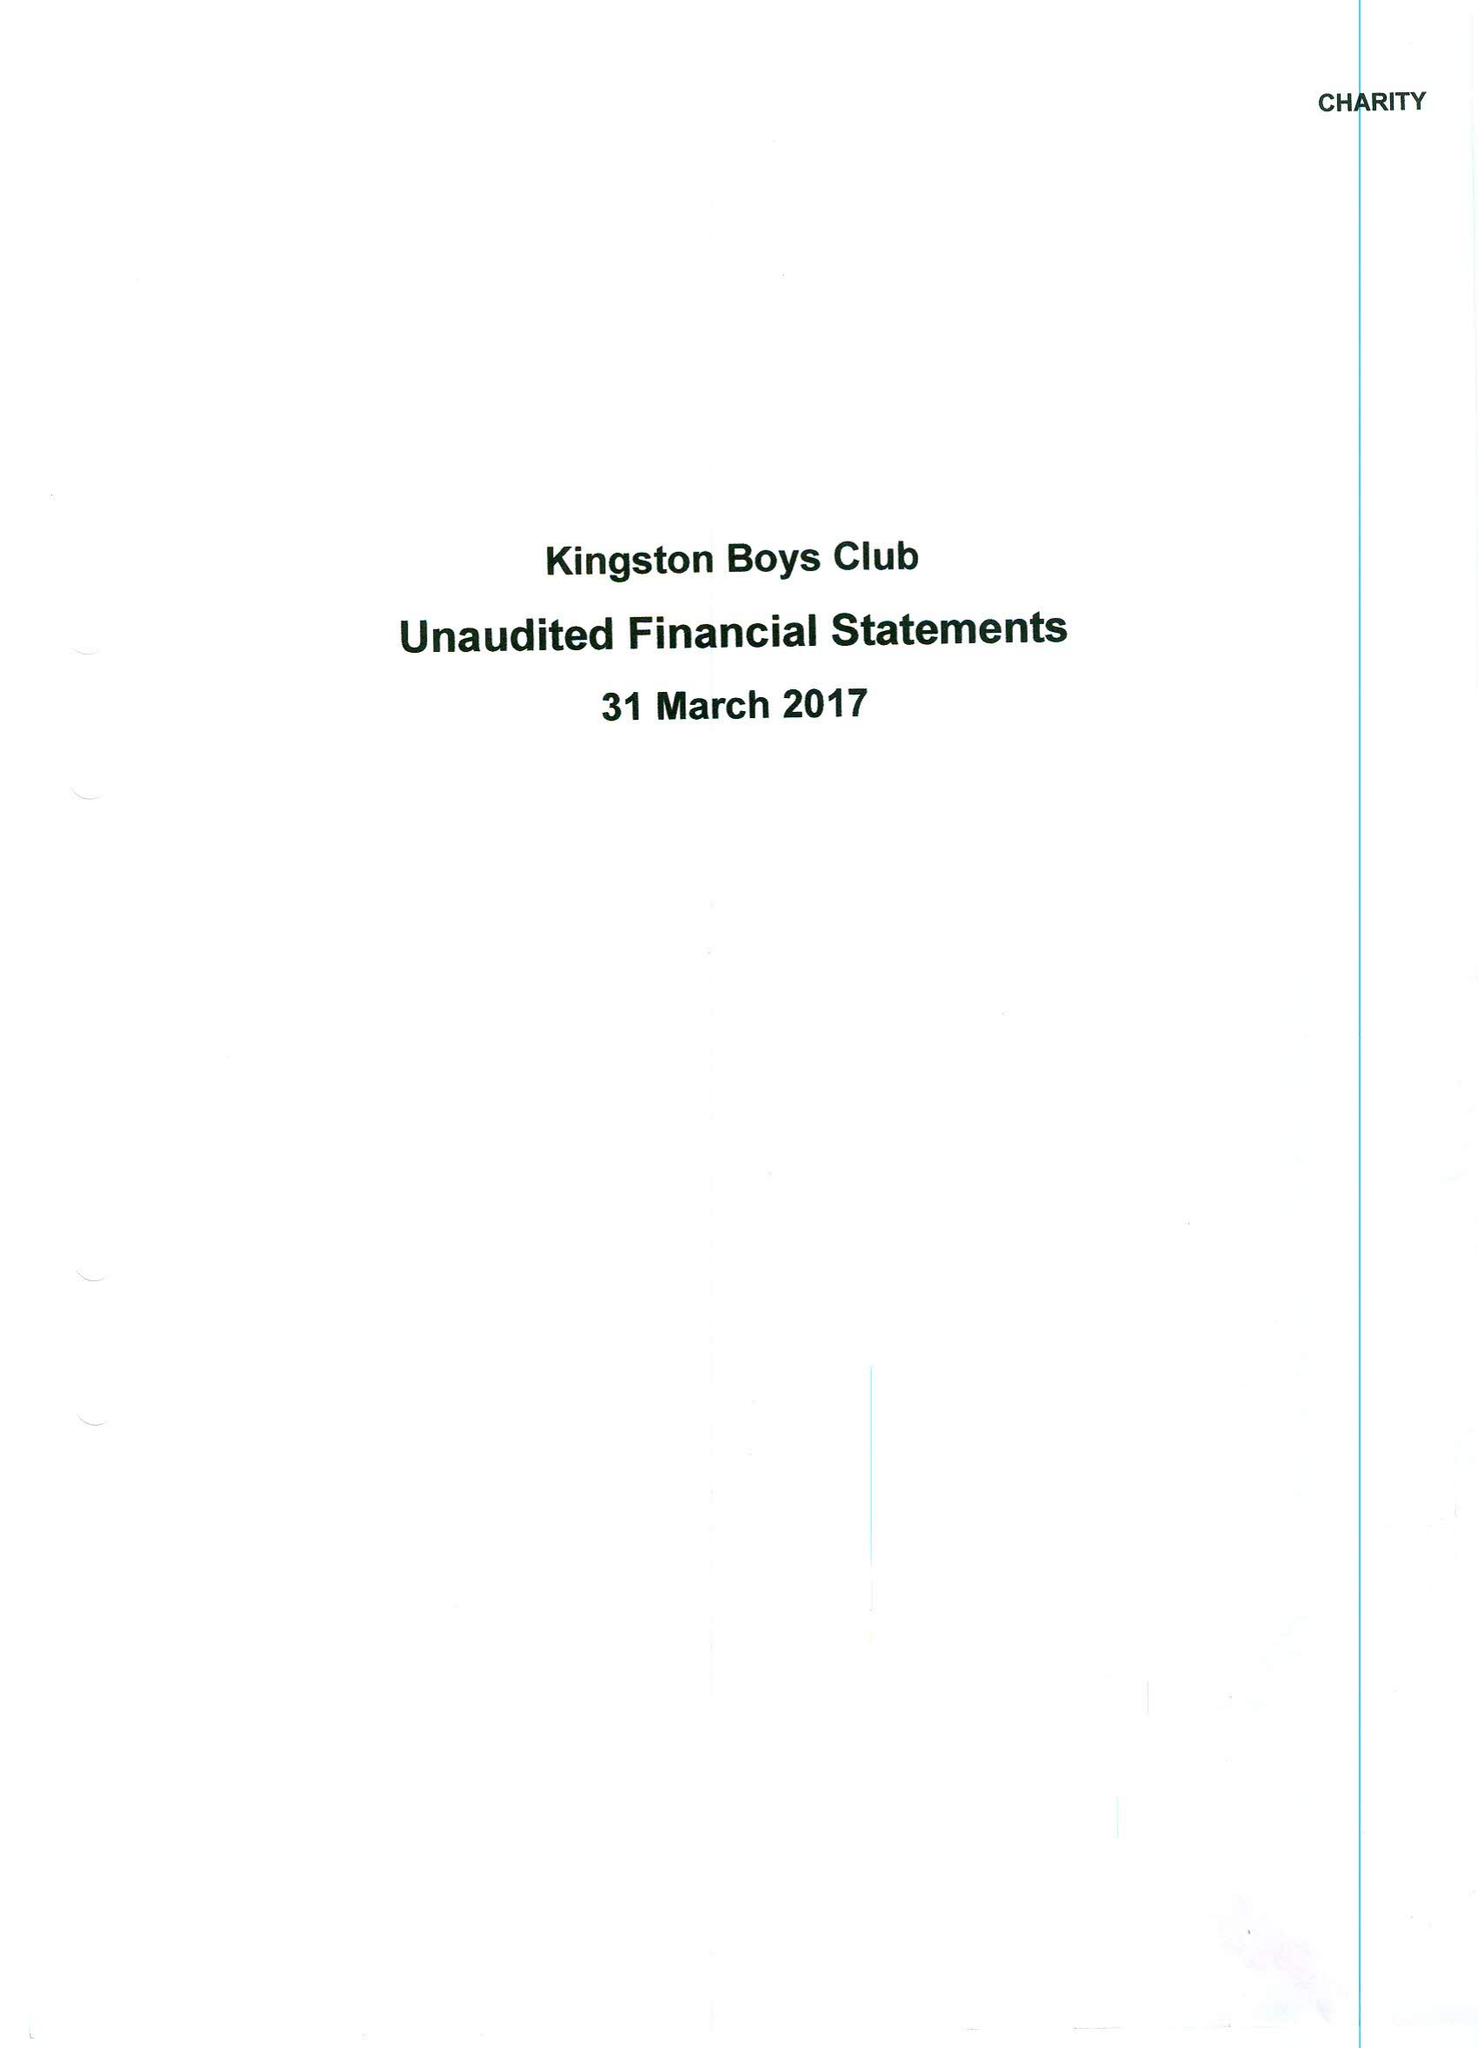What is the value for the address__street_line?
Answer the question using a single word or phrase. 89-91 CLARENCE STREET 